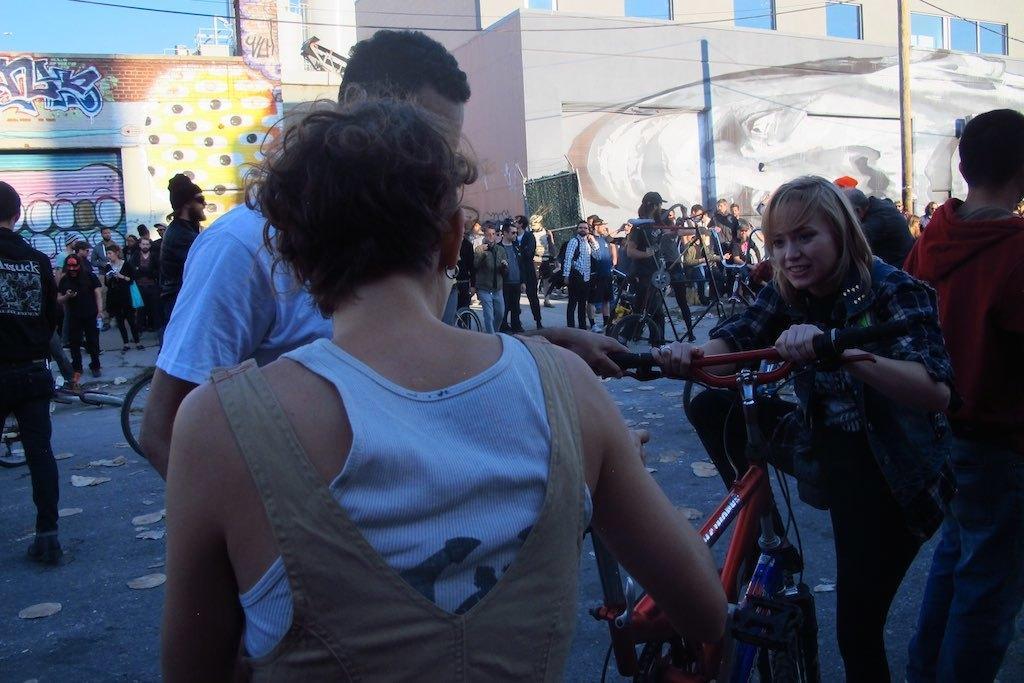How would you summarize this image in a sentence or two? The picture is clicked on a road where many people are standing two people are catching a bicycle , in the background we observe a graffiti made on walls. 